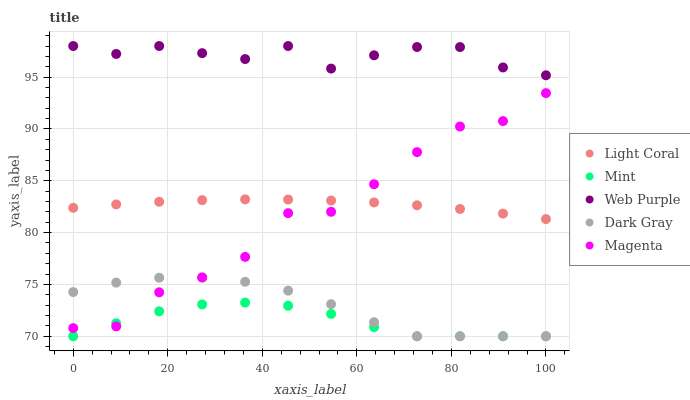Does Mint have the minimum area under the curve?
Answer yes or no. Yes. Does Web Purple have the maximum area under the curve?
Answer yes or no. Yes. Does Dark Gray have the minimum area under the curve?
Answer yes or no. No. Does Dark Gray have the maximum area under the curve?
Answer yes or no. No. Is Light Coral the smoothest?
Answer yes or no. Yes. Is Magenta the roughest?
Answer yes or no. Yes. Is Dark Gray the smoothest?
Answer yes or no. No. Is Dark Gray the roughest?
Answer yes or no. No. Does Dark Gray have the lowest value?
Answer yes or no. Yes. Does Web Purple have the lowest value?
Answer yes or no. No. Does Web Purple have the highest value?
Answer yes or no. Yes. Does Dark Gray have the highest value?
Answer yes or no. No. Is Dark Gray less than Light Coral?
Answer yes or no. Yes. Is Web Purple greater than Mint?
Answer yes or no. Yes. Does Mint intersect Dark Gray?
Answer yes or no. Yes. Is Mint less than Dark Gray?
Answer yes or no. No. Is Mint greater than Dark Gray?
Answer yes or no. No. Does Dark Gray intersect Light Coral?
Answer yes or no. No. 